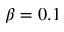<formula> <loc_0><loc_0><loc_500><loc_500>\beta = 0 . 1</formula> 